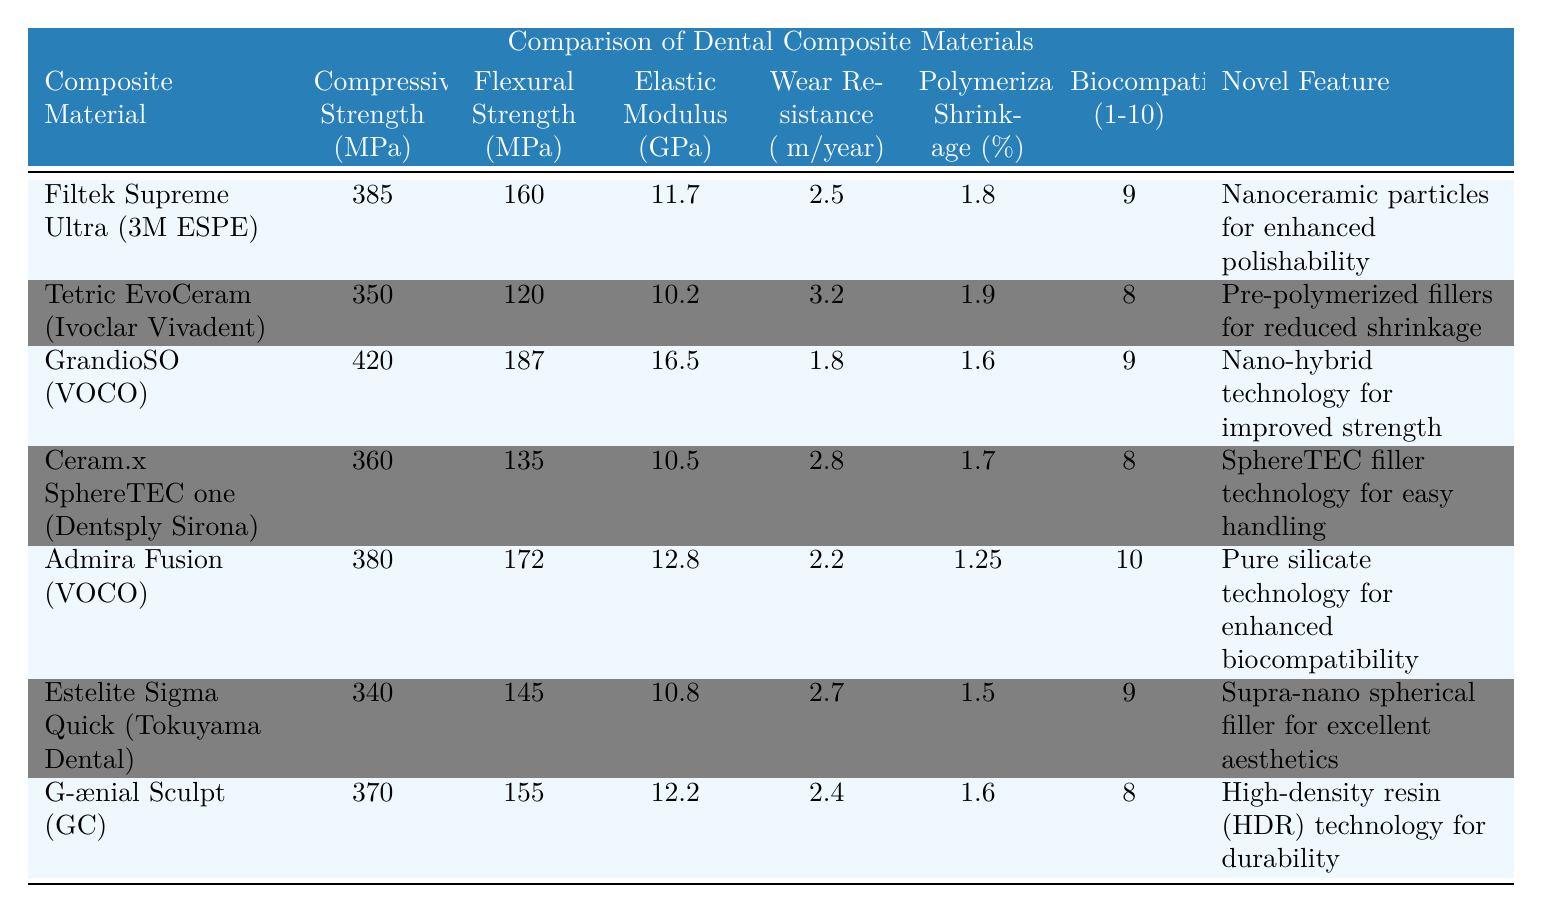What is the highest compressive strength among the materials listed? The compressive strength values are: 385, 350, 420, 360, 380, 340, and 370 MPa. From this list, 420 MPa (GrandioSO) is the highest value.
Answer: 420 MPa Which composite material has the lowest polymerization shrinkage percentage? The polymerization shrinkage percentages are: 1.8, 1.9, 1.6, 1.7, 1.25, 1.5, and 1.6%. The lowest percentage is 1.25%, associated with Admira Fusion.
Answer: 1.25% Is Admira Fusion the only composite material with a biocompatibility score of 10? Upon examining the biocompatibility scores (9, 8, 9, 8, 10, 9, and 8), only Admira Fusion has a score of 10, which confirms that it is indeed the only material with this score.
Answer: Yes What is the average flexural strength of the materials compared? To find the average flexural strength, sum the values: 160 + 120 + 187 + 135 + 172 + 145 + 155 = 1,074 MPa. There are 7 materials, so the average is 1,074 / 7 ≈ 153.43 MPa.
Answer: 153.43 MPa Which material has the best wear resistance and what is the value? The wear resistance values are: 2.5, 3.2, 1.8, 2.8, 2.2, 2.7, and 2.4 μm/year. The best (lowest) wear resistance is 1.8 μm/year, which is associated with GrandioSO.
Answer: 1.8 μm/year What is the elastic modulus of Ceram.x SphereTEC one? The elastic modulus of Ceram.x SphereTEC one is listed as 10.5 GPa in the table.
Answer: 10.5 GPa If we compare polymerization shrinkage percentages, which two materials have the closest values? The polymerization shrinkage percentages are 1.8, 1.9, 1.6, 1.7, 1.25, 1.5, and 1.6%. The closest values are 1.6% (GrandioSO) and 1.6% (G-ænial Sculpt).
Answer: 1.6% (GrandioSO and G-ænial Sculpt) Which composite material offers a novel feature related to ease of handling? The material with a novel feature for ease of handling is Ceram.x SphereTEC one, which utilizes SphereTEC filler technology.
Answer: Ceram.x SphereTEC one 